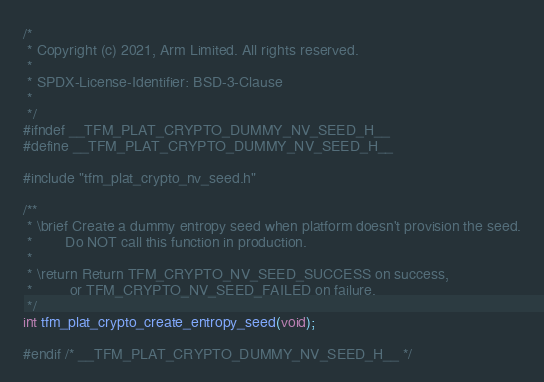Convert code to text. <code><loc_0><loc_0><loc_500><loc_500><_C_>/*
 * Copyright (c) 2021, Arm Limited. All rights reserved.
 *
 * SPDX-License-Identifier: BSD-3-Clause
 *
 */
#ifndef __TFM_PLAT_CRYPTO_DUMMY_NV_SEED_H__
#define __TFM_PLAT_CRYPTO_DUMMY_NV_SEED_H__

#include "tfm_plat_crypto_nv_seed.h"

/**
 * \brief Create a dummy entropy seed when platform doesn't provision the seed.
 *        Do NOT call this function in production.
 *
 * \return Return TFM_CRYPTO_NV_SEED_SUCCESS on success,
 *         or TFM_CRYPTO_NV_SEED_FAILED on failure.
 */
int tfm_plat_crypto_create_entropy_seed(void);

#endif /* __TFM_PLAT_CRYPTO_DUMMY_NV_SEED_H__ */
</code> 